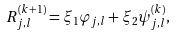Convert formula to latex. <formula><loc_0><loc_0><loc_500><loc_500>R _ { j , l } ^ { ( k + 1 ) } = \xi _ { 1 } \varphi _ { j , l } + \xi _ { 2 } \psi _ { j , l } ^ { ( k ) } ,</formula> 